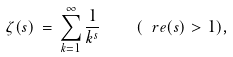Convert formula to latex. <formula><loc_0><loc_0><loc_500><loc_500>\zeta ( s ) \, = \, \sum _ { k = 1 } ^ { \infty } \frac { 1 } { k ^ { s } } \quad ( \ r e ( s ) > 1 ) ,</formula> 